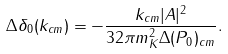<formula> <loc_0><loc_0><loc_500><loc_500>\Delta \delta _ { 0 } ( k _ { c m } ) = - \frac { k _ { c m } | A | ^ { 2 } } { 3 2 \pi m _ { K } ^ { 2 } \Delta ( P _ { 0 } ) _ { c m } } .</formula> 